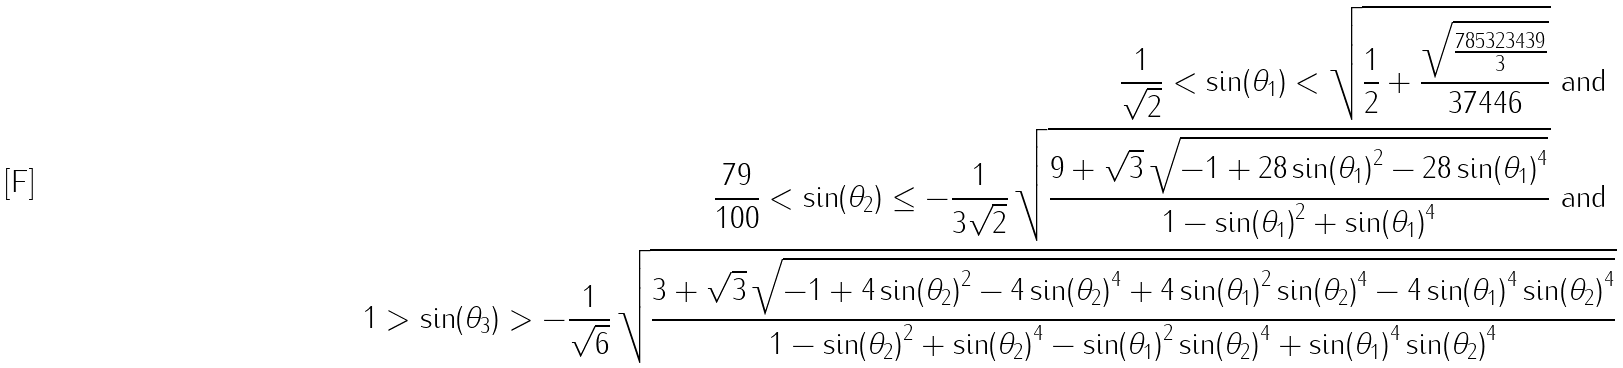Convert formula to latex. <formula><loc_0><loc_0><loc_500><loc_500>\frac { 1 } { { \sqrt { 2 } } } < \sin ( { { \theta } _ { 1 } } ) < { \sqrt { \frac { 1 } { 2 } + \frac { { \sqrt { \frac { 7 8 5 3 2 3 4 3 9 } { 3 } } } } { 3 7 4 4 6 } } } \text { and } \\ \frac { 7 9 } { 1 0 0 } < \sin ( { { \theta } _ { 2 } } ) \leq - { \frac { 1 } { 3 \sqrt { 2 } } } \, { \sqrt { \frac { 9 + { \sqrt { 3 } } \, { \sqrt { - 1 + 2 8 \, { \sin ( { { \theta } _ { 1 } } ) } ^ { 2 } - 2 8 \, { \sin ( { { \theta } _ { 1 } } ) } ^ { 4 } } } } { 1 - { \sin ( { { \theta } _ { 1 } } ) } ^ { 2 } + { \sin ( { { \theta } _ { 1 } } ) } ^ { 4 } } } } \text { and } \\ 1 > \sin ( { { \theta } _ { 3 } } ) > - { \frac { 1 } { \sqrt { 6 } } } \, { \sqrt { \frac { 3 + { \sqrt { 3 } } \, { \sqrt { - 1 + 4 \, { \sin ( { { \theta } _ { 2 } } ) } ^ { 2 } - 4 \, { \sin ( { { \theta } _ { 2 } } ) } ^ { 4 } + 4 \, { \sin ( { { \theta } _ { 1 } } ) } ^ { 2 } \, { \sin ( { { \theta } _ { 2 } } ) } ^ { 4 } - 4 \, { \sin ( { { \theta } _ { 1 } } ) } ^ { 4 } \, { \sin ( { { \theta } _ { 2 } } ) } ^ { 4 } } } } { 1 - { \sin ( { { \theta } _ { 2 } } ) } ^ { 2 } + { \sin ( { { \theta } _ { 2 } } ) } ^ { 4 } - { \sin ( { { \theta } _ { 1 } } ) } ^ { 2 } \, { \sin ( { { \theta } _ { 2 } } ) } ^ { 4 } + { \sin ( { { \theta } _ { 1 } } ) } ^ { 4 } \, { \sin ( { { \theta } _ { 2 } } ) } ^ { 4 } } } }</formula> 